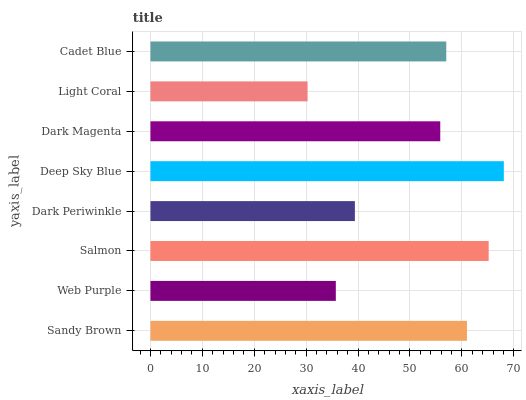Is Light Coral the minimum?
Answer yes or no. Yes. Is Deep Sky Blue the maximum?
Answer yes or no. Yes. Is Web Purple the minimum?
Answer yes or no. No. Is Web Purple the maximum?
Answer yes or no. No. Is Sandy Brown greater than Web Purple?
Answer yes or no. Yes. Is Web Purple less than Sandy Brown?
Answer yes or no. Yes. Is Web Purple greater than Sandy Brown?
Answer yes or no. No. Is Sandy Brown less than Web Purple?
Answer yes or no. No. Is Cadet Blue the high median?
Answer yes or no. Yes. Is Dark Magenta the low median?
Answer yes or no. Yes. Is Dark Magenta the high median?
Answer yes or no. No. Is Web Purple the low median?
Answer yes or no. No. 